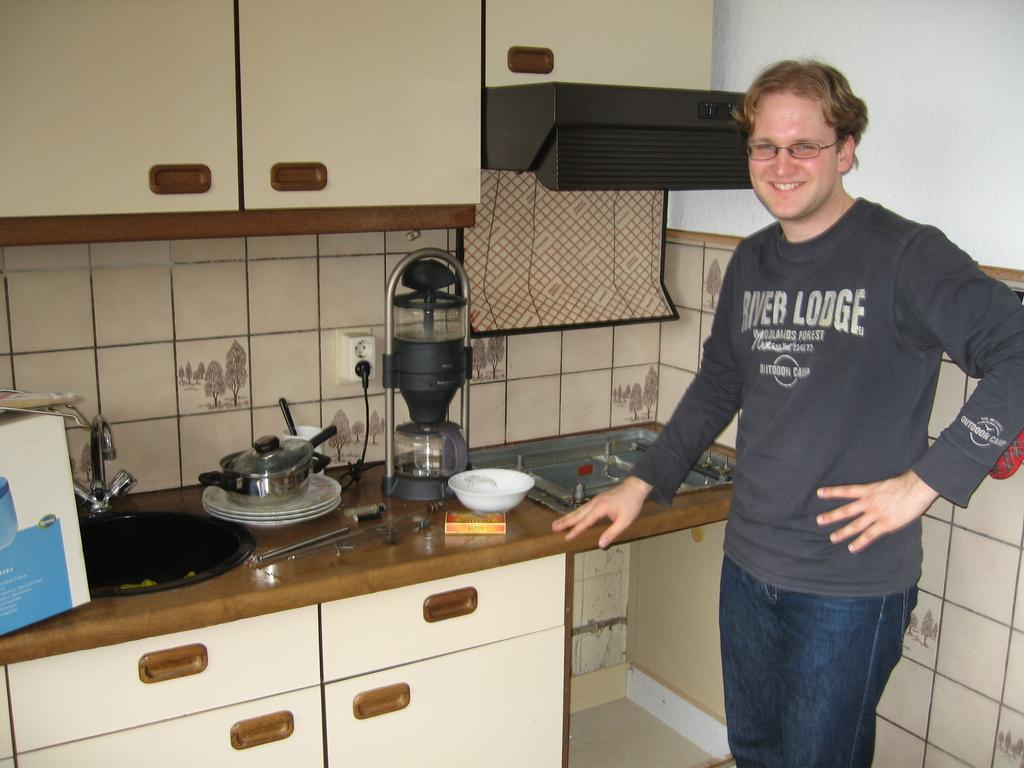<image>
Provide a brief description of the given image. Man in a kitchen wearing a shirt that says: River Lodge: Woodlands Forest Outdoor Camp. 